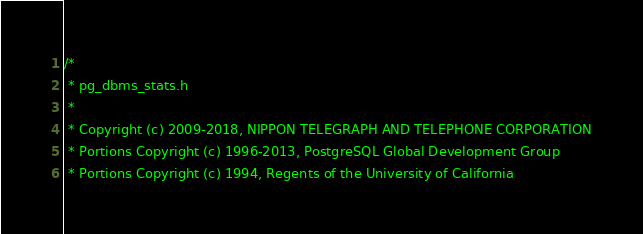<code> <loc_0><loc_0><loc_500><loc_500><_C_>/*
 * pg_dbms_stats.h
 *
 * Copyright (c) 2009-2018, NIPPON TELEGRAPH AND TELEPHONE CORPORATION
 * Portions Copyright (c) 1996-2013, PostgreSQL Global Development Group
 * Portions Copyright (c) 1994, Regents of the University of California</code> 